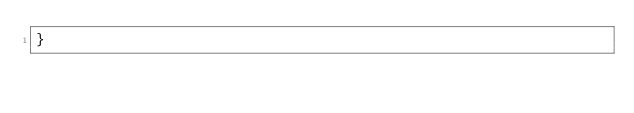Convert code to text. <code><loc_0><loc_0><loc_500><loc_500><_TypeScript_>}
</code> 